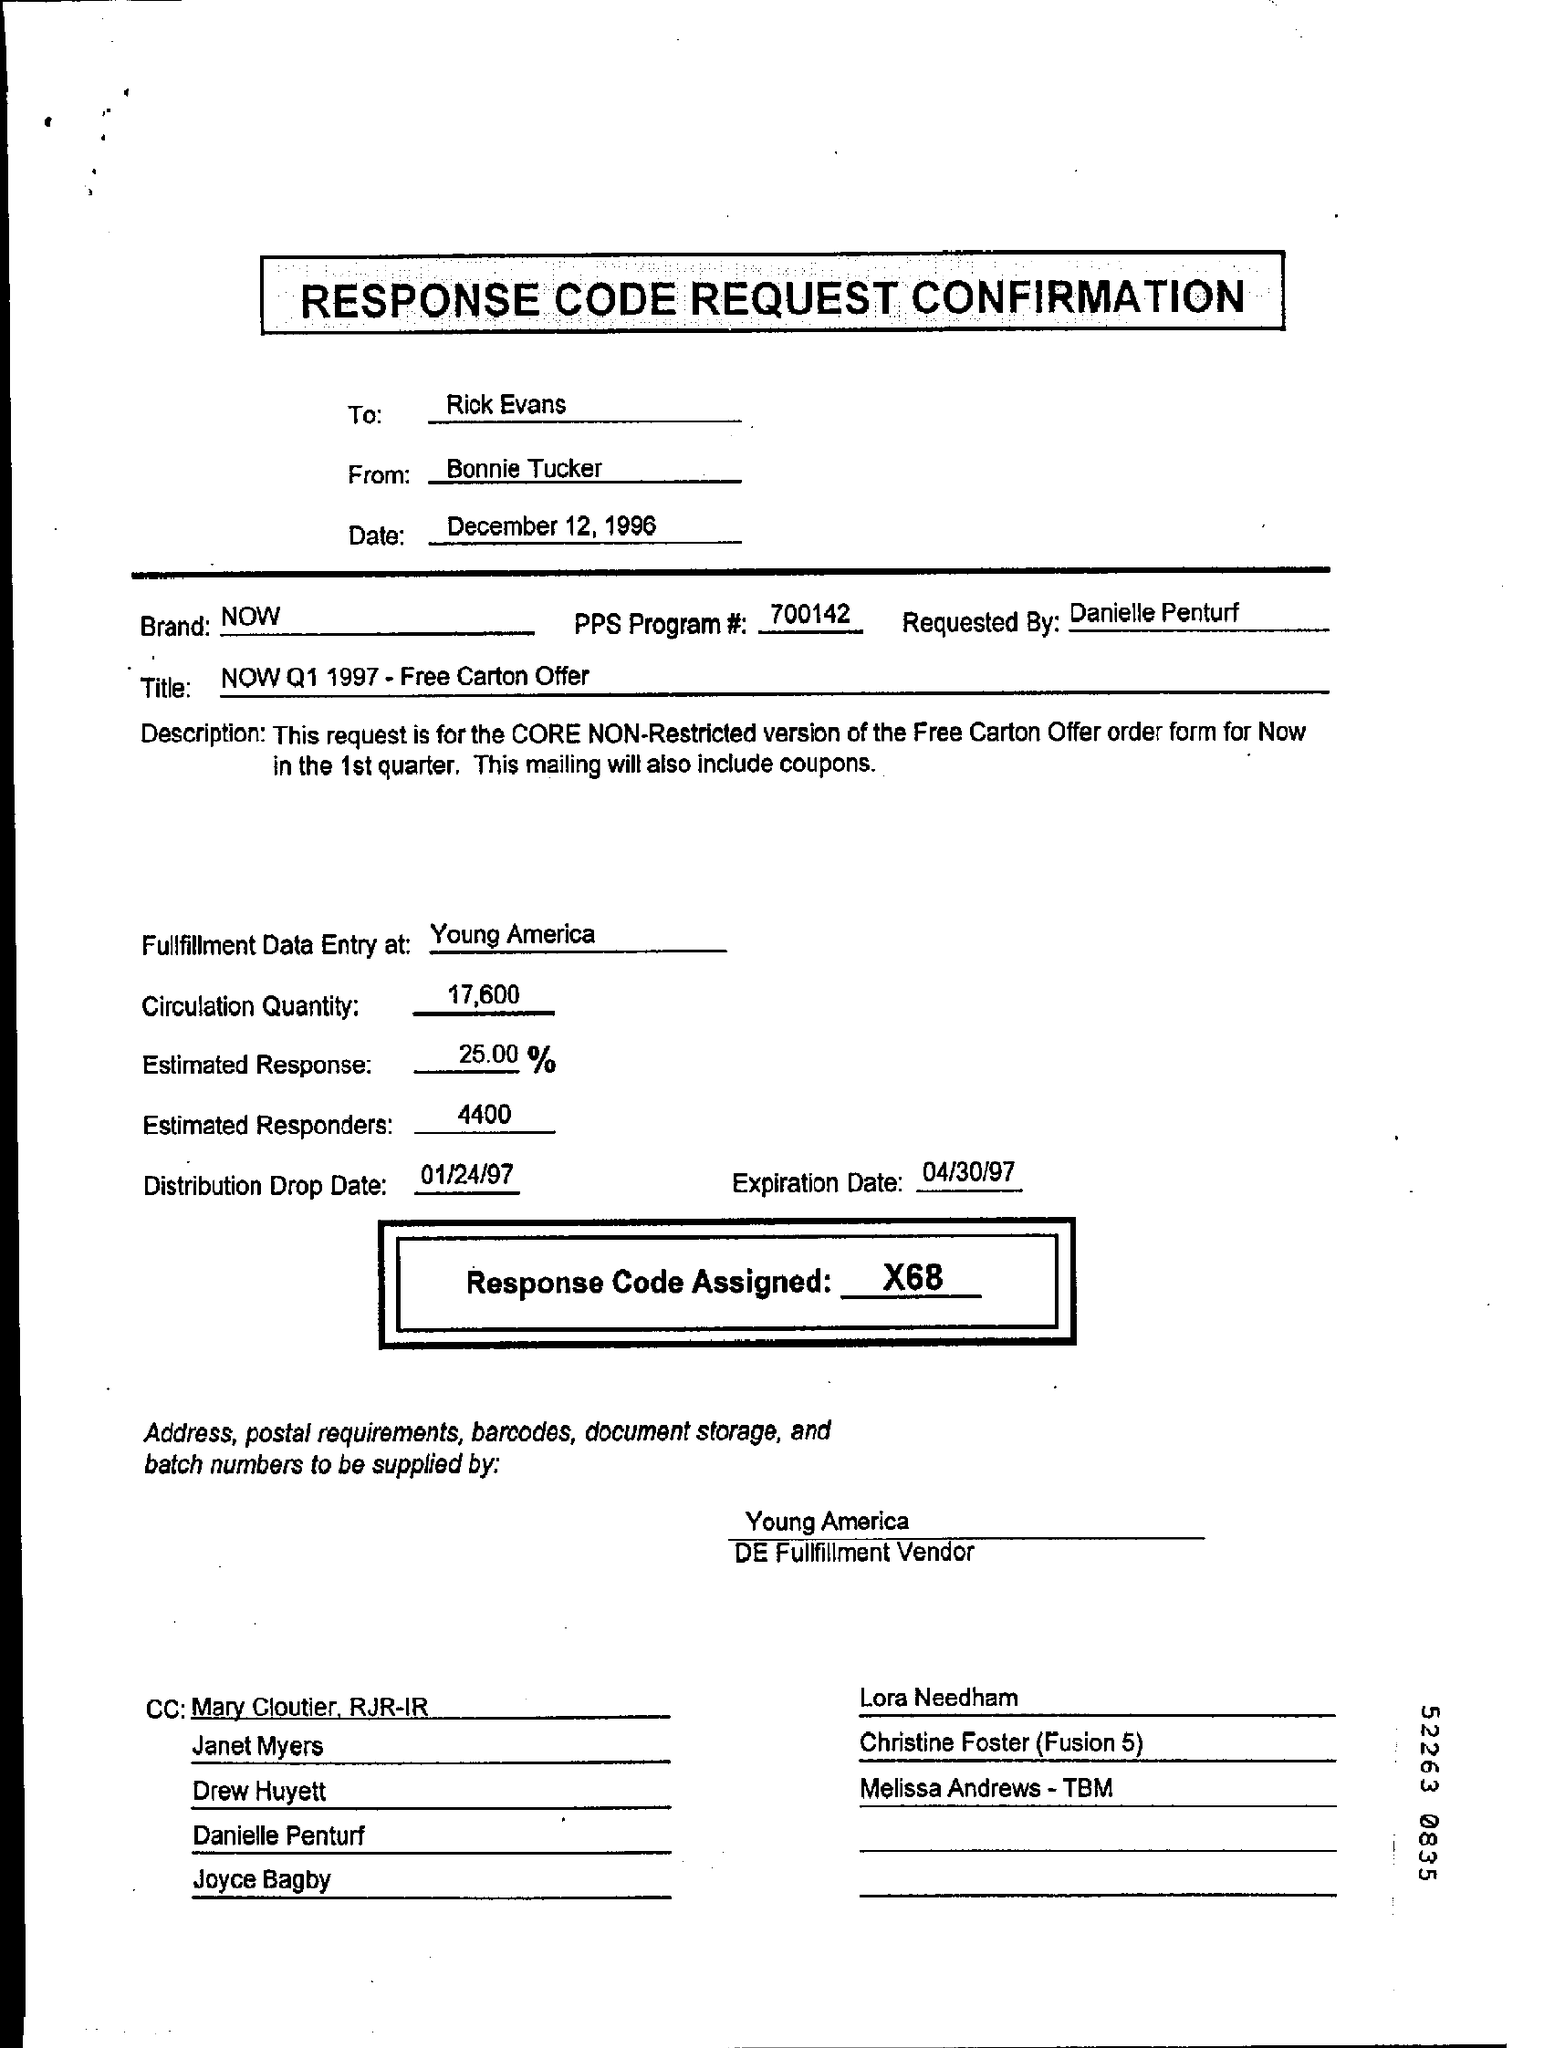Mention a couple of crucial points in this snapshot. The speaker is asking for information about the location of fulfillment data entry for Young America. On what date was the distribution of a specific item recorded? The date in question is 01/24/97. The assigned response code is X68... The estimated responders are approximately 4400. The expiration date is April 30, 1997. 